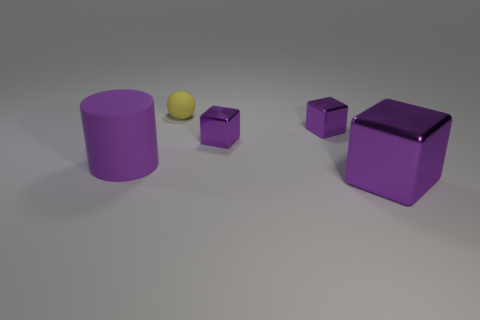Subtract all big blocks. How many blocks are left? 2 Add 1 big objects. How many objects exist? 6 Subtract 1 cubes. How many cubes are left? 2 Subtract all cubes. How many objects are left? 2 Subtract all purple cylinders. Subtract all purple metallic blocks. How many objects are left? 1 Add 2 cylinders. How many cylinders are left? 3 Add 4 big shiny blocks. How many big shiny blocks exist? 5 Subtract 0 gray spheres. How many objects are left? 5 